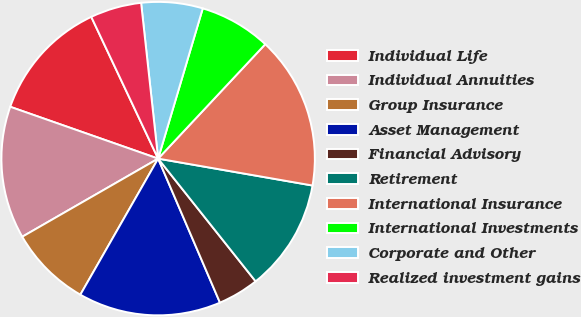Convert chart to OTSL. <chart><loc_0><loc_0><loc_500><loc_500><pie_chart><fcel>Individual Life<fcel>Individual Annuities<fcel>Group Insurance<fcel>Asset Management<fcel>Financial Advisory<fcel>Retirement<fcel>International Insurance<fcel>International Investments<fcel>Corporate and Other<fcel>Realized investment gains<nl><fcel>12.62%<fcel>13.67%<fcel>8.43%<fcel>14.72%<fcel>4.23%<fcel>11.57%<fcel>15.77%<fcel>7.38%<fcel>6.33%<fcel>5.28%<nl></chart> 